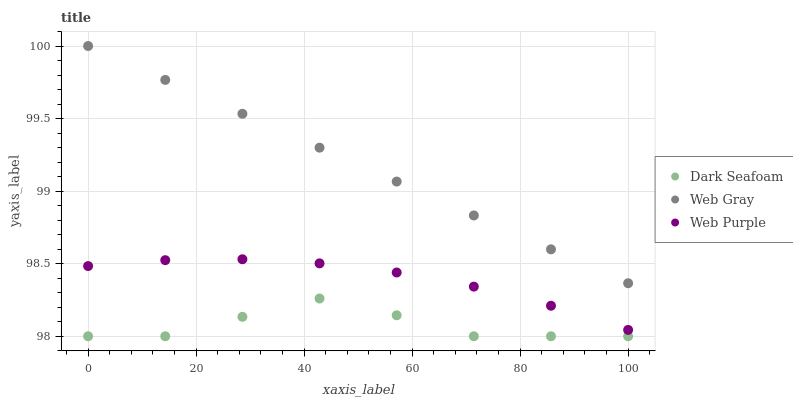Does Dark Seafoam have the minimum area under the curve?
Answer yes or no. Yes. Does Web Gray have the maximum area under the curve?
Answer yes or no. Yes. Does Web Purple have the minimum area under the curve?
Answer yes or no. No. Does Web Purple have the maximum area under the curve?
Answer yes or no. No. Is Web Gray the smoothest?
Answer yes or no. Yes. Is Dark Seafoam the roughest?
Answer yes or no. Yes. Is Web Purple the smoothest?
Answer yes or no. No. Is Web Purple the roughest?
Answer yes or no. No. Does Dark Seafoam have the lowest value?
Answer yes or no. Yes. Does Web Purple have the lowest value?
Answer yes or no. No. Does Web Gray have the highest value?
Answer yes or no. Yes. Does Web Purple have the highest value?
Answer yes or no. No. Is Dark Seafoam less than Web Purple?
Answer yes or no. Yes. Is Web Gray greater than Web Purple?
Answer yes or no. Yes. Does Dark Seafoam intersect Web Purple?
Answer yes or no. No. 